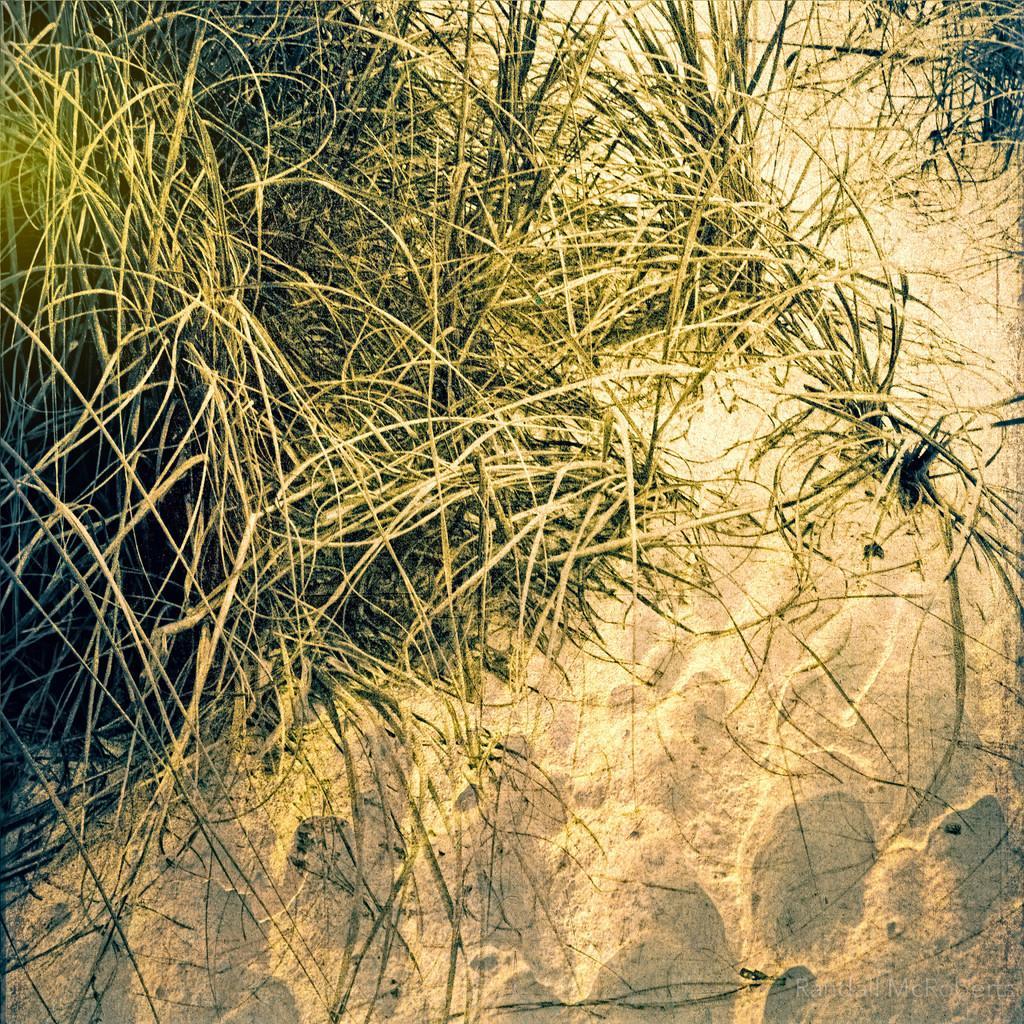Please provide a concise description of this image. In this picture I can see sand, grass and there is a watermark on the image. 